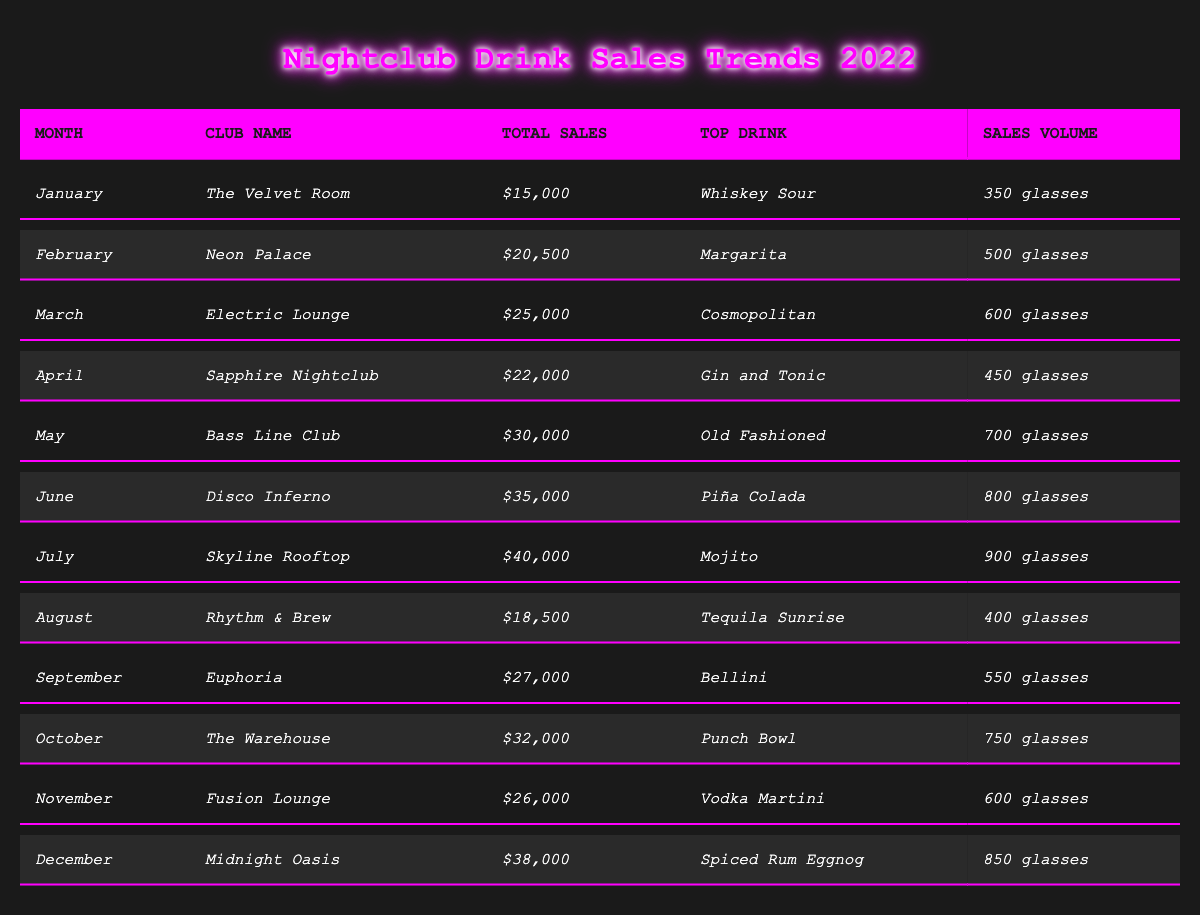What was the total sales in June? From the table, we can find the row corresponding to June, where the total sales is listed as *$35,000*.
Answer: $35,000 Which drink was the top seller in July? The row for July shows that the top drink sold was a *Mojito*.
Answer: Mojito What is the average total sales across all clubs? To find the average, we first sum the total sales from each month: ($15,000 + $20,500 + $25,000 + $22,000 + $30,000 + $35,000 + $40,000 + $18,500 + $27,000 + $32,000 + $26,000 + $38,000) = $  5 1 2 0 0 0. There are 12 months, so average sales = $  5 1 2 0 0 0 / 12  = $  4 2 6 6 6 7  .67, which is rounded to $  4 2 6 6 7 for simplicity.
Answer: $ 4 2 6 6 6 7 How many glasses of the *Piña Colada* were sold in June? Checking the June row, we see that *800 glasses* of Piña Colada were sold.
Answer: 800 glasses Did more glasses of drinks get sold in October than in August? The October row shows *750 glasses* while August shows *400 glasses*. Comparing these values, October sold more glasses than August.
Answer: Yes What was the month with the highest total sales? By examining the total sales figures for all months, we find that July had the highest total sales at *$40,000*.
Answer: July How much more in total sales did the *Skyline Rooftop* make in July compared to *Rhythm & Brew* in August? The total sales for Skyline Rooftop in July is *$40,000* and for Rhythm & Brew in August is *$18,500*. The difference in sales is $40,000 - $18,500 = $21,500.
Answer: $21,500 Was the top drink in April the same as in September? The table shows the top drink for April as *Gin and Tonic* and for September as *Bellini*, which are different drinks.
Answer: No What percentage of total sales in December corresponds to the sales volume of the top drink? December's total sales are *$38,000*, and the top drink sold *850 glasses*. The sales volume for December top drink isn’t directly comparable to total sales without the price per glass information; thus, we can't compute this accurately.
Answer: Cannot determine Which month had a total sales amount less than $20,000? Scanning through the table, the only month with sales below $20,000 is January, with *$15,000* total sales.
Answer: January 